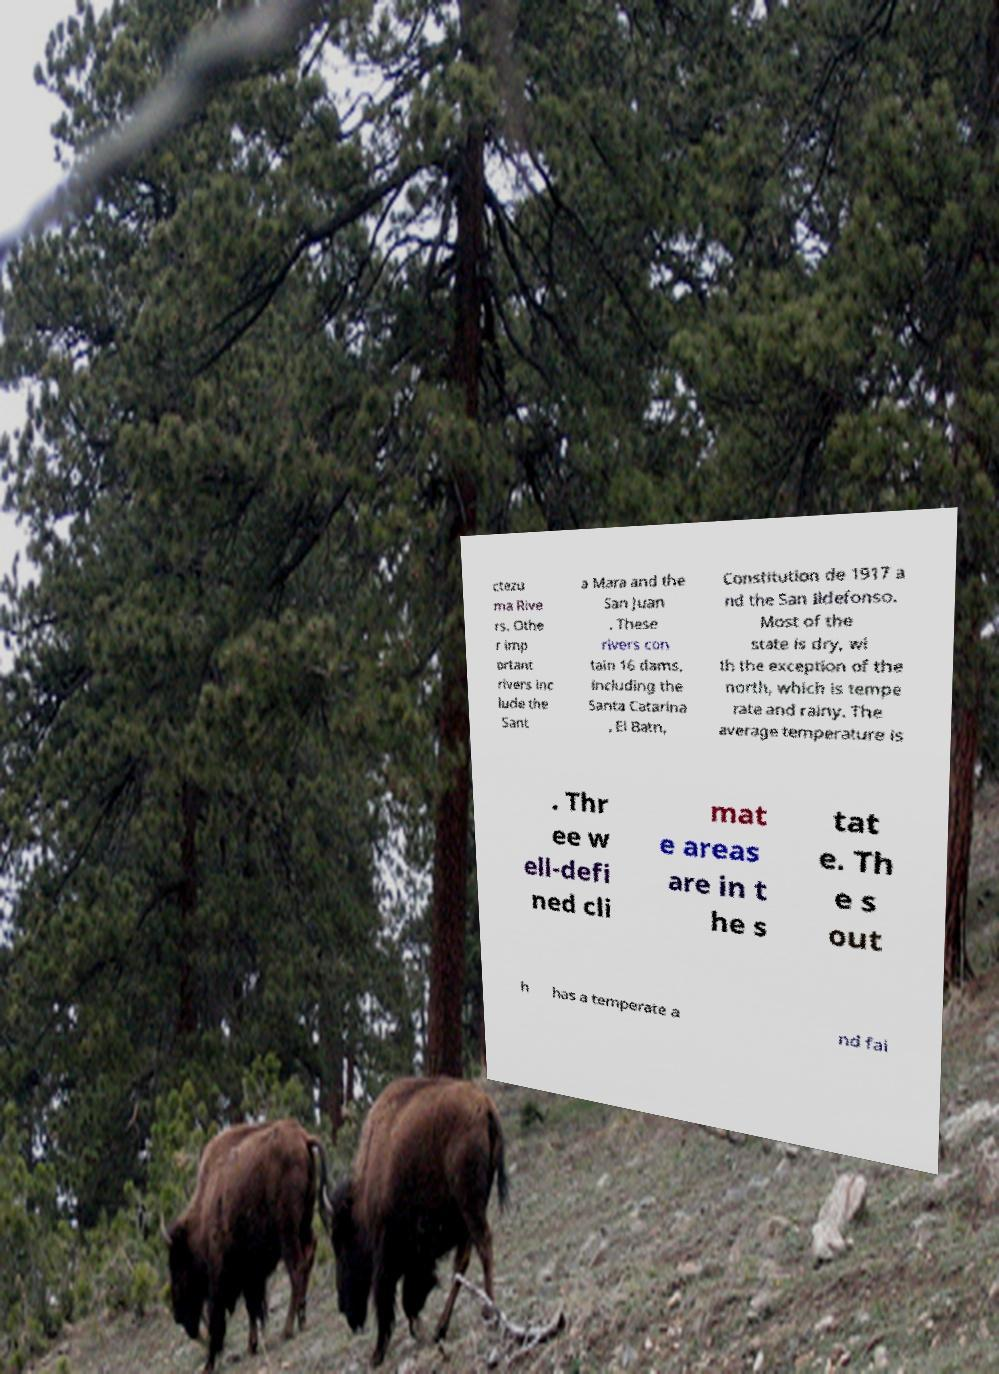Please identify and transcribe the text found in this image. ctezu ma Rive rs. Othe r imp ortant rivers inc lude the Sant a Mara and the San Juan . These rivers con tain 16 dams, including the Santa Catarina , El Batn, Constitution de 1917 a nd the San Ildefonso. Most of the state is dry, wi th the exception of the north, which is tempe rate and rainy. The average temperature is . Thr ee w ell-defi ned cli mat e areas are in t he s tat e. Th e s out h has a temperate a nd fai 